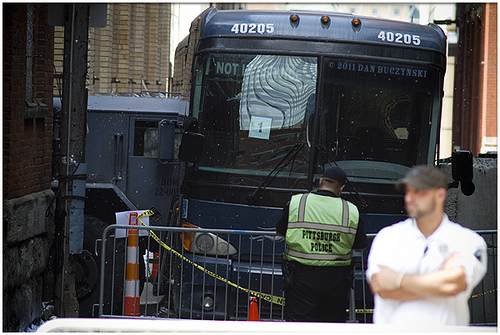<image>
Is there a vehicle to the right of the policeman? No. The vehicle is not to the right of the policeman. The horizontal positioning shows a different relationship. 